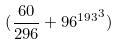<formula> <loc_0><loc_0><loc_500><loc_500>( \frac { 6 0 } { 2 9 6 } + { 9 6 ^ { 1 9 3 } } ^ { 3 } )</formula> 